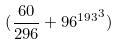<formula> <loc_0><loc_0><loc_500><loc_500>( \frac { 6 0 } { 2 9 6 } + { 9 6 ^ { 1 9 3 } } ^ { 3 } )</formula> 